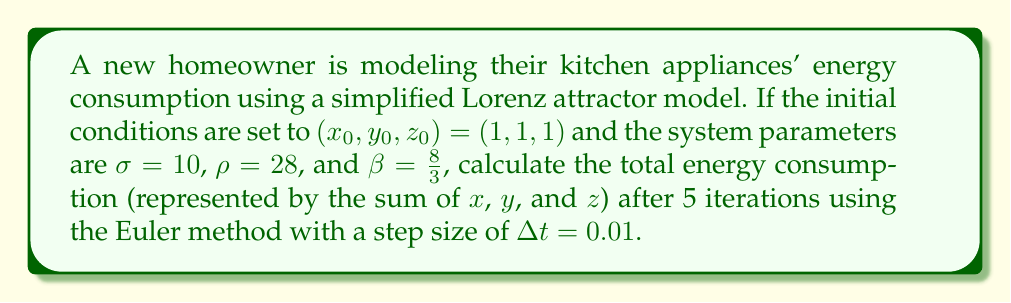Provide a solution to this math problem. To solve this problem, we'll use the Lorenz attractor equations and the Euler method:

1) The Lorenz attractor equations are:
   $$\frac{dx}{dt} = \sigma(y - x)$$
   $$\frac{dy}{dt} = x(\rho - z) - y$$
   $$\frac{dz}{dt} = xy - \beta z$$

2) The Euler method for a system of differential equations is:
   $$x_{n+1} = x_n + \Delta t \cdot f(x_n, y_n, z_n)$$
   $$y_{n+1} = y_n + \Delta t \cdot g(x_n, y_n, z_n)$$
   $$z_{n+1} = z_n + \Delta t \cdot h(x_n, y_n, z_n)$$

3) Substituting the Lorenz equations into the Euler method:
   $$x_{n+1} = x_n + \Delta t \cdot \sigma(y_n - x_n)$$
   $$y_{n+1} = y_n + \Delta t \cdot (x_n(\rho - z_n) - y_n)$$
   $$z_{n+1} = z_n + \Delta t \cdot (x_ny_n - \beta z_n)$$

4) Now, let's iterate 5 times with $\Delta t = 0.01$:

   Iteration 1:
   $x_1 = 1 + 0.01 \cdot 10(1 - 1) = 1$
   $y_1 = 1 + 0.01 \cdot (1(28 - 1) - 1) = 1.26$
   $z_1 = 1 + 0.01 \cdot (1 \cdot 1 - \frac{8}{3} \cdot 1) = 0.9833$

   Iteration 2:
   $x_2 = 1 + 0.01 \cdot 10(1.26 - 1) = 1.026$
   $y_2 = 1.26 + 0.01 \cdot (1(28 - 0.9833) - 1.26) = 1.5204$
   $z_2 = 0.9833 + 0.01 \cdot (1 \cdot 1.26 - \frac{8}{3} \cdot 0.9833) = 0.9696$

   Iteration 3:
   $x_3 = 1.026 + 0.01 \cdot 10(1.5204 - 1.026) = 1.0754$
   $y_3 = 1.5204 + 0.01 \cdot (1.026(28 - 0.9696) - 1.5204) = 1.7912$
   $z_3 = 0.9696 + 0.01 \cdot (1.026 \cdot 1.5204 - \frac{8}{3} \cdot 0.9696) = 0.9603$

   Iteration 4:
   $x_4 = 1.0754 + 0.01 \cdot 10(1.7912 - 1.0754) = 1.1470$
   $y_4 = 1.7912 + 0.01 \cdot (1.0754(28 - 0.9603) - 1.7912) = 2.0727$
   $z_4 = 0.9603 + 0.01 \cdot (1.0754 \cdot 1.7912 - \frac{8}{3} \cdot 0.9603) = 0.9567$

   Iteration 5:
   $x_5 = 1.1470 + 0.01 \cdot 10(2.0727 - 1.1470) = 1.2396$
   $y_5 = 2.0727 + 0.01 \cdot (1.1470(28 - 0.9567) - 2.0727) = 2.3651$
   $z_5 = 0.9567 + 0.01 \cdot (1.1470 \cdot 2.0727 - \frac{8}{3} \cdot 0.9567) = 0.9597$

5) The total energy consumption is the sum of $x_5$, $y_5$, and $z_5$:
   $1.2396 + 2.3651 + 0.9597 = 4.5644$
Answer: 4.5644 